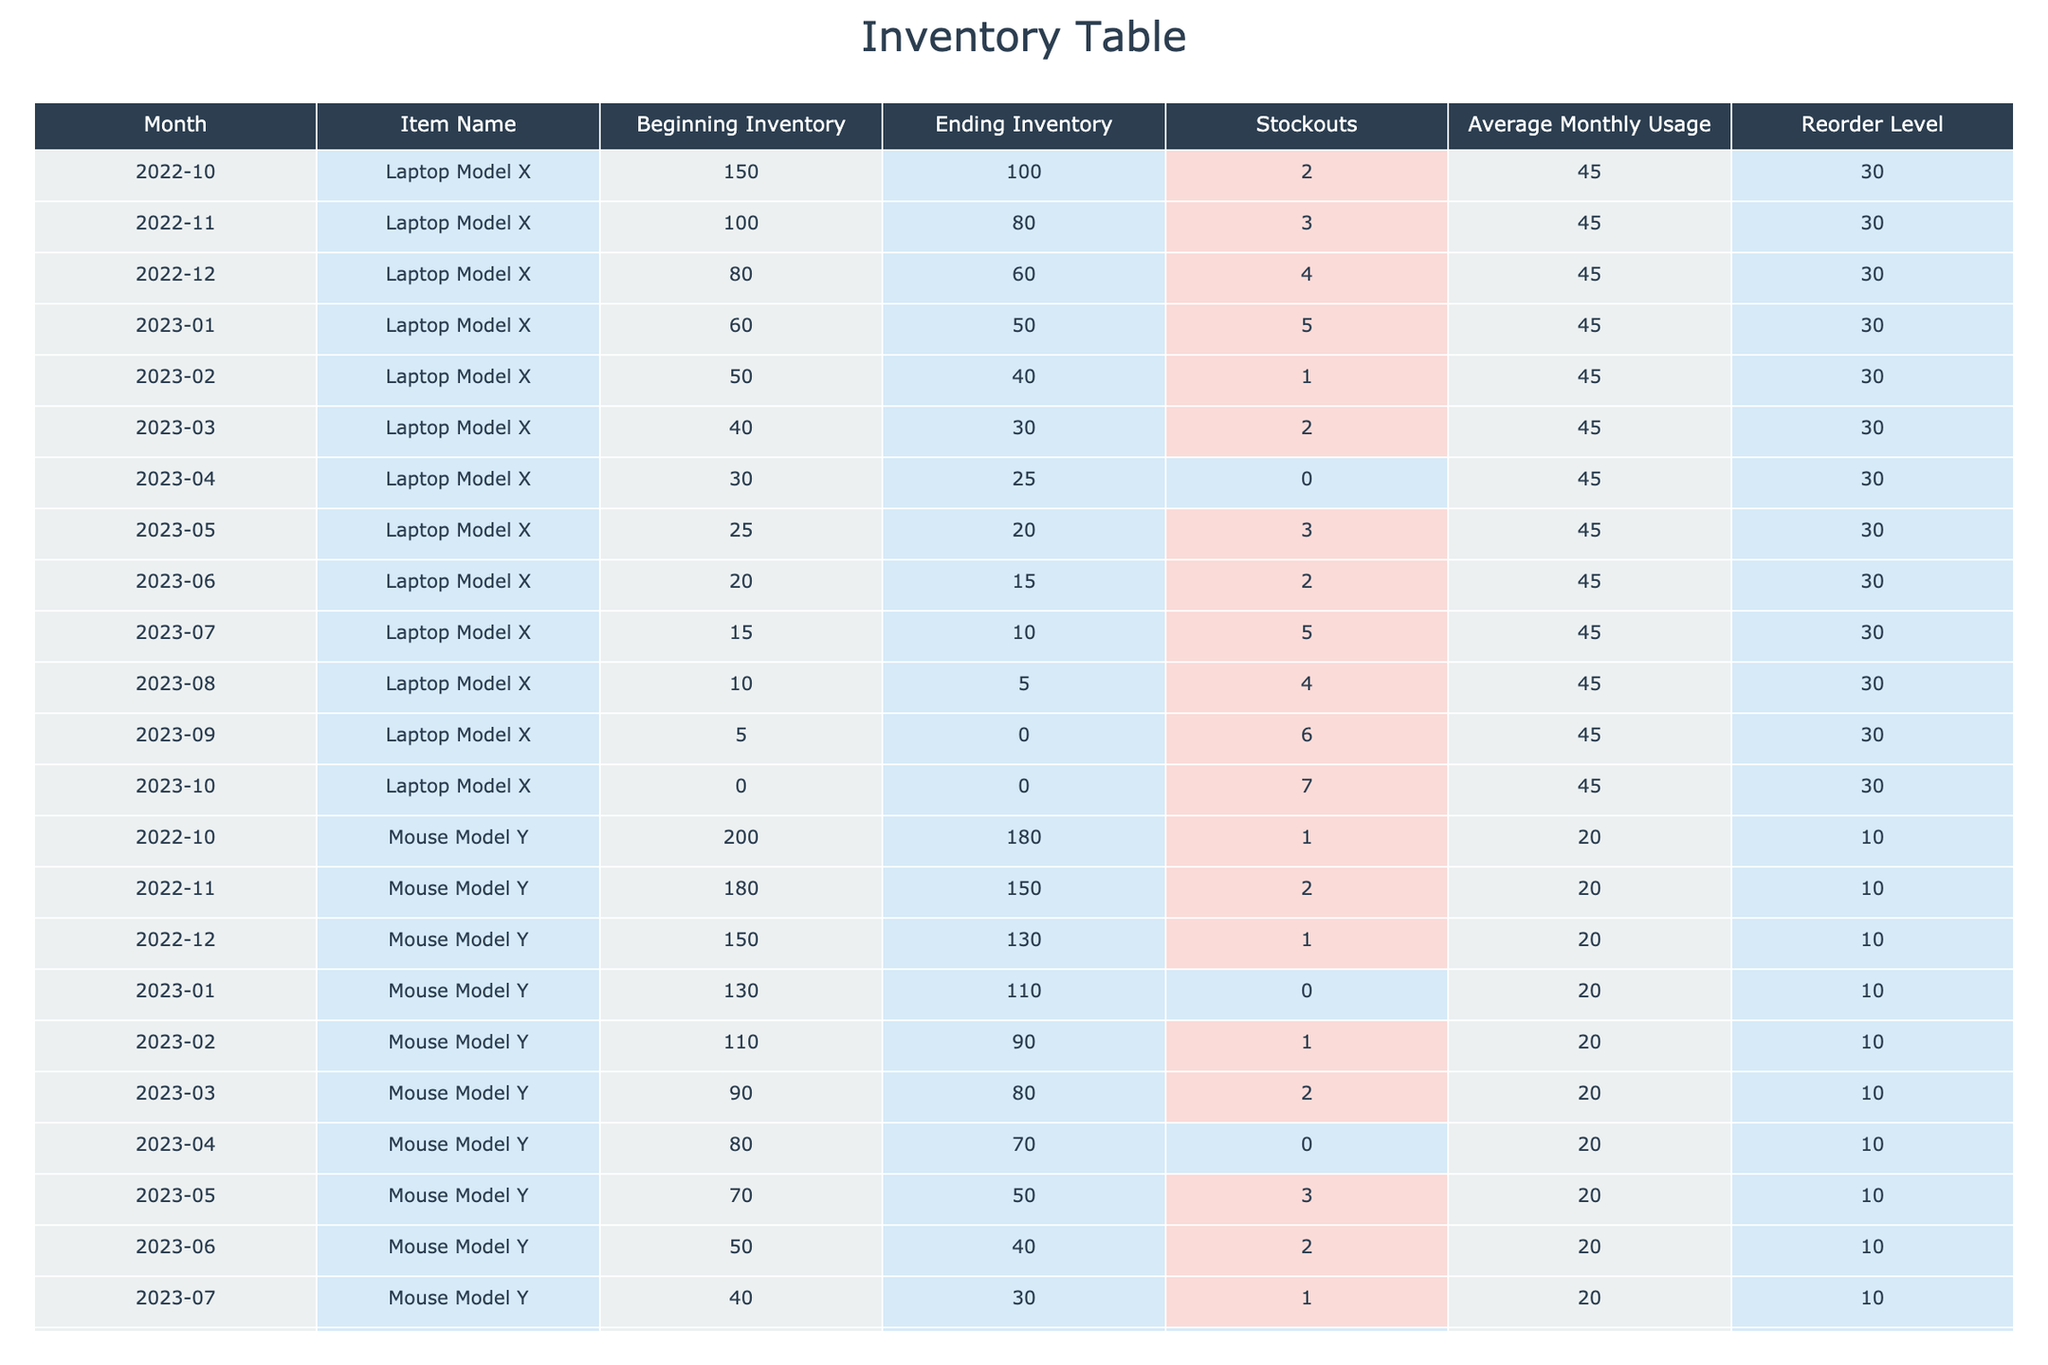What is the average beginning inventory for Laptop Model X over the last year? To find the average, we sum the beginning inventory amounts for each month where Laptop Model X is listed and then divide by the number of months. The amounts are 150, 100, 80, 60, 50, 40, 30, 25, 20, 15, 10, and 0, giving a total of 560. There are 12 months, so the average is 560/12 = 46.67
Answer: 46.67 How many stockouts occurred in total for Mouse Model Y over the last year? We sum the stockouts for each month for Mouse Model Y. The stockout counts are 1, 2, 1, 0, 1, 2, 0, 3, 2, 1, 0, and 4, resulting in a total of 16 stockouts when summed up.
Answer: 16 Was there any month where Laptop Model X had no stockouts? We check each month's stockout value for Laptop Model X. The record shows that in April 2023, there were 0 stockouts. Therefore, the statement is true.
Answer: Yes What was the highest average monthly usage of Laptop Model X recorded, and in which month did it occur? The average monthly usage for Laptop Model X is consistent at 45 units across all months. Thus, there is no month with a higher average recorded.
Answer: 45 in all months What are the ending inventory levels for Laptop Model X in the month with the highest stockouts? The highest number of stockouts for Laptop Model X occurred in October 2023 with 7 stockouts. Checking the ending inventory for that month, it was recorded as 0.
Answer: 0 Did Mouse Model Y maintain a stock level above reorder level every month? We compare the ending inventory levels with the reorder level of 10 units for each month of Mouse Model Y. The ending inventories fell below this level in October 2023, indicating that the statement is false.
Answer: No In how many months did Laptop Model X have an ending inventory below 20 units? We list the ending inventory for Laptop Model X and identify those months with levels lower than 20: the months were July (10), August (5), September (0), and October (0), making it a total of four months.
Answer: 4 What is the difference in beginning inventory for Mouse Model Y between October 2022 and August 2023? The beginning inventory for Mouse Model Y in October 2022 was 200, and in August 2023 it was 30. To find the difference, we calculate 200 - 30 = 170.
Answer: 170 How many months had a stockout count of more than 2 for Laptop Model X? We check the stockout count for Laptop Model X each month. The months with more than 2 stockouts are November (3), December (4), January (5), May (3), July (5), August (4), September (6), and October (7), totaling 7 months.
Answer: 7 